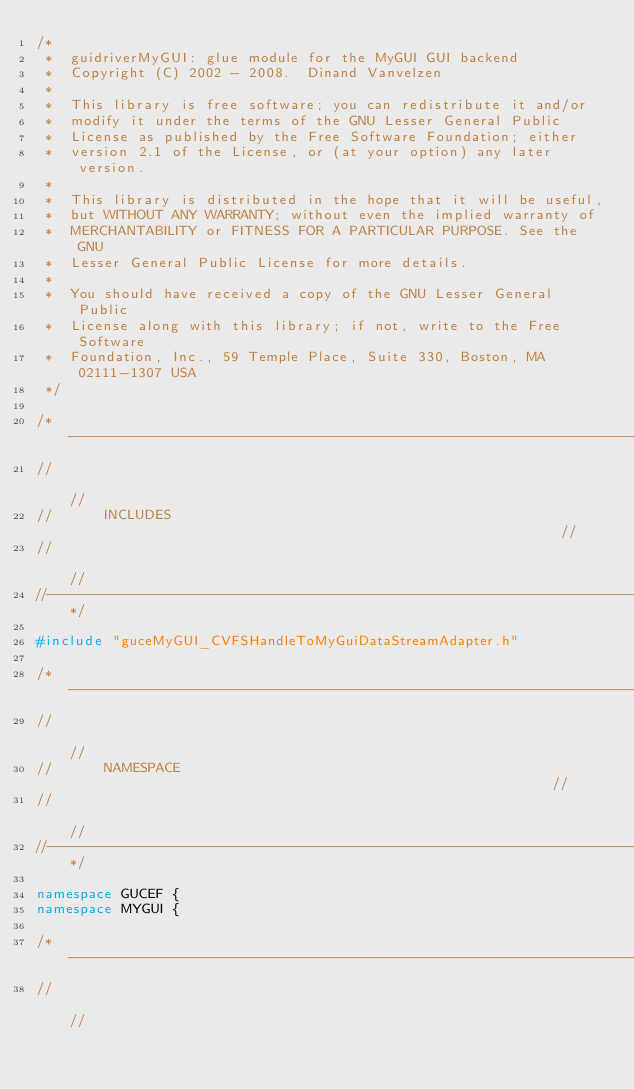<code> <loc_0><loc_0><loc_500><loc_500><_C++_>/*
 *  guidriverMyGUI: glue module for the MyGUI GUI backend
 *  Copyright (C) 2002 - 2008.  Dinand Vanvelzen
 *
 *  This library is free software; you can redistribute it and/or
 *  modify it under the terms of the GNU Lesser General Public
 *  License as published by the Free Software Foundation; either
 *  version 2.1 of the License, or (at your option) any later version.
 *
 *  This library is distributed in the hope that it will be useful,
 *  but WITHOUT ANY WARRANTY; without even the implied warranty of
 *  MERCHANTABILITY or FITNESS FOR A PARTICULAR PURPOSE. See the GNU
 *  Lesser General Public License for more details.
 *
 *  You should have received a copy of the GNU Lesser General Public
 *  License along with this library; if not, write to the Free Software
 *  Foundation, Inc., 59 Temple Place, Suite 330, Boston, MA 02111-1307 USA
 */

/*-------------------------------------------------------------------------//
//                                                                         //
//      INCLUDES                                                           //
//                                                                         //
//-------------------------------------------------------------------------*/

#include "guceMyGUI_CVFSHandleToMyGuiDataStreamAdapter.h"

/*-------------------------------------------------------------------------//
//                                                                         //
//      NAMESPACE                                                          //
//                                                                         //
//-------------------------------------------------------------------------*/

namespace GUCEF {
namespace MYGUI {

/*-------------------------------------------------------------------------//
//                                                                         //</code> 